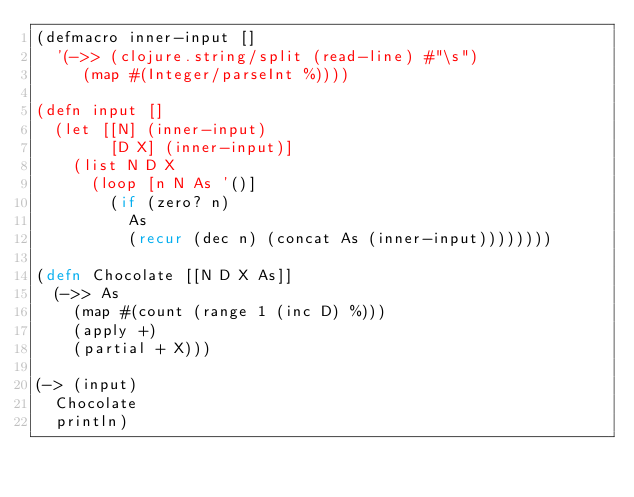<code> <loc_0><loc_0><loc_500><loc_500><_Clojure_>(defmacro inner-input []
  '(->> (clojure.string/split (read-line) #"\s")
     (map #(Integer/parseInt %))))

(defn input []
  (let [[N] (inner-input)
        [D X] (inner-input)]
    (list N D X
      (loop [n N As '()]
        (if (zero? n)
          As
          (recur (dec n) (concat As (inner-input))))))))

(defn Chocolate [[N D X As]]
  (->> As
    (map #(count (range 1 (inc D) %)))
    (apply +)
    (partial + X)))

(-> (input)
  Chocolate
  println)</code> 